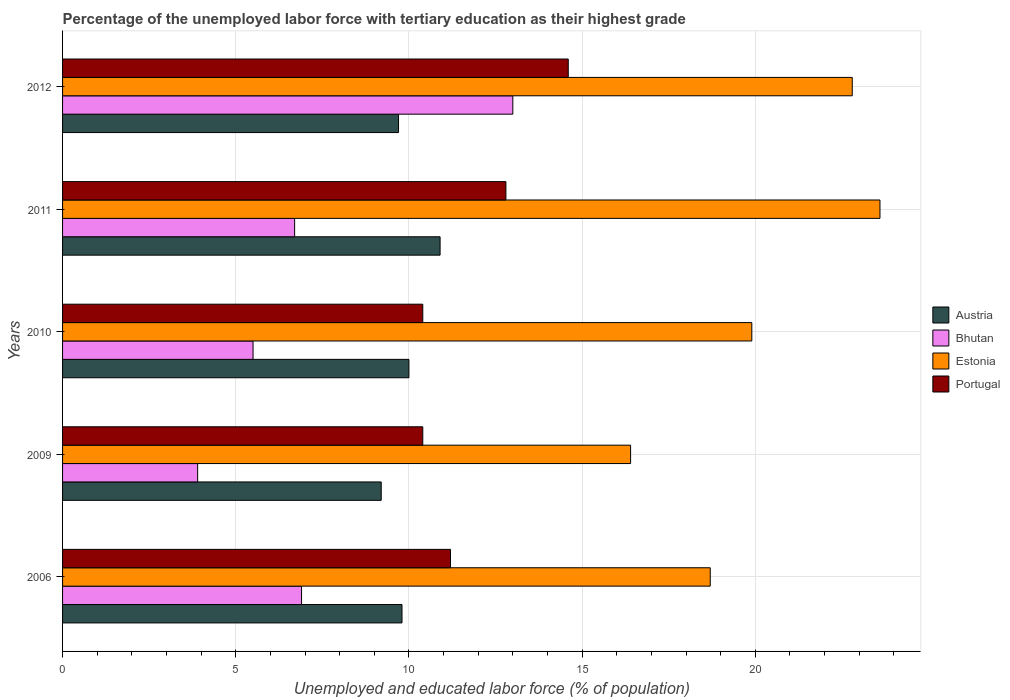Are the number of bars per tick equal to the number of legend labels?
Provide a succinct answer. Yes. Are the number of bars on each tick of the Y-axis equal?
Provide a succinct answer. Yes. What is the label of the 5th group of bars from the top?
Provide a short and direct response. 2006. In how many cases, is the number of bars for a given year not equal to the number of legend labels?
Keep it short and to the point. 0. What is the percentage of the unemployed labor force with tertiary education in Estonia in 2006?
Provide a short and direct response. 18.7. Across all years, what is the maximum percentage of the unemployed labor force with tertiary education in Estonia?
Your answer should be compact. 23.6. Across all years, what is the minimum percentage of the unemployed labor force with tertiary education in Estonia?
Ensure brevity in your answer.  16.4. In which year was the percentage of the unemployed labor force with tertiary education in Portugal maximum?
Make the answer very short. 2012. What is the total percentage of the unemployed labor force with tertiary education in Portugal in the graph?
Give a very brief answer. 59.4. What is the difference between the percentage of the unemployed labor force with tertiary education in Estonia in 2010 and that in 2012?
Make the answer very short. -2.9. What is the difference between the percentage of the unemployed labor force with tertiary education in Bhutan in 2006 and the percentage of the unemployed labor force with tertiary education in Portugal in 2012?
Offer a very short reply. -7.7. What is the average percentage of the unemployed labor force with tertiary education in Bhutan per year?
Provide a short and direct response. 7.2. In the year 2006, what is the difference between the percentage of the unemployed labor force with tertiary education in Estonia and percentage of the unemployed labor force with tertiary education in Portugal?
Keep it short and to the point. 7.5. In how many years, is the percentage of the unemployed labor force with tertiary education in Estonia greater than 19 %?
Provide a succinct answer. 3. What is the ratio of the percentage of the unemployed labor force with tertiary education in Portugal in 2006 to that in 2012?
Your answer should be compact. 0.77. Is the difference between the percentage of the unemployed labor force with tertiary education in Estonia in 2009 and 2012 greater than the difference between the percentage of the unemployed labor force with tertiary education in Portugal in 2009 and 2012?
Offer a terse response. No. What is the difference between the highest and the second highest percentage of the unemployed labor force with tertiary education in Bhutan?
Keep it short and to the point. 6.1. What is the difference between the highest and the lowest percentage of the unemployed labor force with tertiary education in Austria?
Ensure brevity in your answer.  1.7. In how many years, is the percentage of the unemployed labor force with tertiary education in Estonia greater than the average percentage of the unemployed labor force with tertiary education in Estonia taken over all years?
Provide a succinct answer. 2. What does the 4th bar from the top in 2010 represents?
Offer a terse response. Austria. What does the 2nd bar from the bottom in 2012 represents?
Offer a terse response. Bhutan. Is it the case that in every year, the sum of the percentage of the unemployed labor force with tertiary education in Estonia and percentage of the unemployed labor force with tertiary education in Portugal is greater than the percentage of the unemployed labor force with tertiary education in Austria?
Your answer should be very brief. Yes. Are all the bars in the graph horizontal?
Give a very brief answer. Yes. What is the difference between two consecutive major ticks on the X-axis?
Ensure brevity in your answer.  5. Are the values on the major ticks of X-axis written in scientific E-notation?
Provide a succinct answer. No. Does the graph contain any zero values?
Provide a succinct answer. No. What is the title of the graph?
Make the answer very short. Percentage of the unemployed labor force with tertiary education as their highest grade. What is the label or title of the X-axis?
Your answer should be compact. Unemployed and educated labor force (% of population). What is the Unemployed and educated labor force (% of population) in Austria in 2006?
Keep it short and to the point. 9.8. What is the Unemployed and educated labor force (% of population) in Bhutan in 2006?
Make the answer very short. 6.9. What is the Unemployed and educated labor force (% of population) in Estonia in 2006?
Provide a short and direct response. 18.7. What is the Unemployed and educated labor force (% of population) of Portugal in 2006?
Give a very brief answer. 11.2. What is the Unemployed and educated labor force (% of population) in Austria in 2009?
Your answer should be very brief. 9.2. What is the Unemployed and educated labor force (% of population) in Bhutan in 2009?
Keep it short and to the point. 3.9. What is the Unemployed and educated labor force (% of population) of Estonia in 2009?
Provide a short and direct response. 16.4. What is the Unemployed and educated labor force (% of population) in Portugal in 2009?
Make the answer very short. 10.4. What is the Unemployed and educated labor force (% of population) in Estonia in 2010?
Your answer should be compact. 19.9. What is the Unemployed and educated labor force (% of population) in Portugal in 2010?
Give a very brief answer. 10.4. What is the Unemployed and educated labor force (% of population) in Austria in 2011?
Ensure brevity in your answer.  10.9. What is the Unemployed and educated labor force (% of population) of Bhutan in 2011?
Ensure brevity in your answer.  6.7. What is the Unemployed and educated labor force (% of population) in Estonia in 2011?
Your answer should be very brief. 23.6. What is the Unemployed and educated labor force (% of population) of Portugal in 2011?
Your answer should be very brief. 12.8. What is the Unemployed and educated labor force (% of population) of Austria in 2012?
Make the answer very short. 9.7. What is the Unemployed and educated labor force (% of population) of Bhutan in 2012?
Your response must be concise. 13. What is the Unemployed and educated labor force (% of population) in Estonia in 2012?
Your response must be concise. 22.8. What is the Unemployed and educated labor force (% of population) in Portugal in 2012?
Offer a terse response. 14.6. Across all years, what is the maximum Unemployed and educated labor force (% of population) in Austria?
Your answer should be very brief. 10.9. Across all years, what is the maximum Unemployed and educated labor force (% of population) of Estonia?
Keep it short and to the point. 23.6. Across all years, what is the maximum Unemployed and educated labor force (% of population) in Portugal?
Your response must be concise. 14.6. Across all years, what is the minimum Unemployed and educated labor force (% of population) of Austria?
Your answer should be compact. 9.2. Across all years, what is the minimum Unemployed and educated labor force (% of population) in Bhutan?
Make the answer very short. 3.9. Across all years, what is the minimum Unemployed and educated labor force (% of population) in Estonia?
Provide a succinct answer. 16.4. Across all years, what is the minimum Unemployed and educated labor force (% of population) in Portugal?
Your answer should be very brief. 10.4. What is the total Unemployed and educated labor force (% of population) in Austria in the graph?
Your response must be concise. 49.6. What is the total Unemployed and educated labor force (% of population) of Bhutan in the graph?
Provide a short and direct response. 36. What is the total Unemployed and educated labor force (% of population) in Estonia in the graph?
Your answer should be compact. 101.4. What is the total Unemployed and educated labor force (% of population) of Portugal in the graph?
Keep it short and to the point. 59.4. What is the difference between the Unemployed and educated labor force (% of population) of Bhutan in 2006 and that in 2009?
Give a very brief answer. 3. What is the difference between the Unemployed and educated labor force (% of population) of Estonia in 2006 and that in 2009?
Make the answer very short. 2.3. What is the difference between the Unemployed and educated labor force (% of population) of Portugal in 2006 and that in 2009?
Provide a short and direct response. 0.8. What is the difference between the Unemployed and educated labor force (% of population) in Estonia in 2006 and that in 2010?
Your answer should be compact. -1.2. What is the difference between the Unemployed and educated labor force (% of population) of Portugal in 2006 and that in 2010?
Ensure brevity in your answer.  0.8. What is the difference between the Unemployed and educated labor force (% of population) of Austria in 2006 and that in 2011?
Keep it short and to the point. -1.1. What is the difference between the Unemployed and educated labor force (% of population) in Portugal in 2006 and that in 2012?
Keep it short and to the point. -3.4. What is the difference between the Unemployed and educated labor force (% of population) of Bhutan in 2009 and that in 2010?
Offer a terse response. -1.6. What is the difference between the Unemployed and educated labor force (% of population) in Estonia in 2009 and that in 2010?
Make the answer very short. -3.5. What is the difference between the Unemployed and educated labor force (% of population) in Estonia in 2009 and that in 2011?
Keep it short and to the point. -7.2. What is the difference between the Unemployed and educated labor force (% of population) of Portugal in 2009 and that in 2011?
Give a very brief answer. -2.4. What is the difference between the Unemployed and educated labor force (% of population) in Bhutan in 2009 and that in 2012?
Your answer should be compact. -9.1. What is the difference between the Unemployed and educated labor force (% of population) of Portugal in 2009 and that in 2012?
Keep it short and to the point. -4.2. What is the difference between the Unemployed and educated labor force (% of population) of Bhutan in 2010 and that in 2012?
Offer a terse response. -7.5. What is the difference between the Unemployed and educated labor force (% of population) in Estonia in 2010 and that in 2012?
Your answer should be compact. -2.9. What is the difference between the Unemployed and educated labor force (% of population) of Bhutan in 2011 and that in 2012?
Your answer should be very brief. -6.3. What is the difference between the Unemployed and educated labor force (% of population) in Portugal in 2011 and that in 2012?
Ensure brevity in your answer.  -1.8. What is the difference between the Unemployed and educated labor force (% of population) in Austria in 2006 and the Unemployed and educated labor force (% of population) in Portugal in 2009?
Provide a succinct answer. -0.6. What is the difference between the Unemployed and educated labor force (% of population) of Bhutan in 2006 and the Unemployed and educated labor force (% of population) of Estonia in 2009?
Your response must be concise. -9.5. What is the difference between the Unemployed and educated labor force (% of population) in Estonia in 2006 and the Unemployed and educated labor force (% of population) in Portugal in 2009?
Make the answer very short. 8.3. What is the difference between the Unemployed and educated labor force (% of population) in Austria in 2006 and the Unemployed and educated labor force (% of population) in Estonia in 2010?
Your answer should be very brief. -10.1. What is the difference between the Unemployed and educated labor force (% of population) of Bhutan in 2006 and the Unemployed and educated labor force (% of population) of Estonia in 2010?
Offer a terse response. -13. What is the difference between the Unemployed and educated labor force (% of population) in Austria in 2006 and the Unemployed and educated labor force (% of population) in Bhutan in 2011?
Make the answer very short. 3.1. What is the difference between the Unemployed and educated labor force (% of population) in Austria in 2006 and the Unemployed and educated labor force (% of population) in Estonia in 2011?
Give a very brief answer. -13.8. What is the difference between the Unemployed and educated labor force (% of population) in Bhutan in 2006 and the Unemployed and educated labor force (% of population) in Estonia in 2011?
Provide a short and direct response. -16.7. What is the difference between the Unemployed and educated labor force (% of population) of Bhutan in 2006 and the Unemployed and educated labor force (% of population) of Portugal in 2011?
Give a very brief answer. -5.9. What is the difference between the Unemployed and educated labor force (% of population) of Estonia in 2006 and the Unemployed and educated labor force (% of population) of Portugal in 2011?
Keep it short and to the point. 5.9. What is the difference between the Unemployed and educated labor force (% of population) of Austria in 2006 and the Unemployed and educated labor force (% of population) of Estonia in 2012?
Your answer should be compact. -13. What is the difference between the Unemployed and educated labor force (% of population) of Bhutan in 2006 and the Unemployed and educated labor force (% of population) of Estonia in 2012?
Provide a short and direct response. -15.9. What is the difference between the Unemployed and educated labor force (% of population) of Bhutan in 2006 and the Unemployed and educated labor force (% of population) of Portugal in 2012?
Ensure brevity in your answer.  -7.7. What is the difference between the Unemployed and educated labor force (% of population) in Estonia in 2006 and the Unemployed and educated labor force (% of population) in Portugal in 2012?
Your answer should be very brief. 4.1. What is the difference between the Unemployed and educated labor force (% of population) in Bhutan in 2009 and the Unemployed and educated labor force (% of population) in Portugal in 2010?
Provide a succinct answer. -6.5. What is the difference between the Unemployed and educated labor force (% of population) in Austria in 2009 and the Unemployed and educated labor force (% of population) in Estonia in 2011?
Provide a short and direct response. -14.4. What is the difference between the Unemployed and educated labor force (% of population) in Bhutan in 2009 and the Unemployed and educated labor force (% of population) in Estonia in 2011?
Offer a very short reply. -19.7. What is the difference between the Unemployed and educated labor force (% of population) in Bhutan in 2009 and the Unemployed and educated labor force (% of population) in Portugal in 2011?
Offer a terse response. -8.9. What is the difference between the Unemployed and educated labor force (% of population) of Estonia in 2009 and the Unemployed and educated labor force (% of population) of Portugal in 2011?
Offer a terse response. 3.6. What is the difference between the Unemployed and educated labor force (% of population) in Austria in 2009 and the Unemployed and educated labor force (% of population) in Bhutan in 2012?
Provide a short and direct response. -3.8. What is the difference between the Unemployed and educated labor force (% of population) of Austria in 2009 and the Unemployed and educated labor force (% of population) of Estonia in 2012?
Offer a very short reply. -13.6. What is the difference between the Unemployed and educated labor force (% of population) of Austria in 2009 and the Unemployed and educated labor force (% of population) of Portugal in 2012?
Give a very brief answer. -5.4. What is the difference between the Unemployed and educated labor force (% of population) of Bhutan in 2009 and the Unemployed and educated labor force (% of population) of Estonia in 2012?
Your answer should be very brief. -18.9. What is the difference between the Unemployed and educated labor force (% of population) of Austria in 2010 and the Unemployed and educated labor force (% of population) of Bhutan in 2011?
Ensure brevity in your answer.  3.3. What is the difference between the Unemployed and educated labor force (% of population) of Austria in 2010 and the Unemployed and educated labor force (% of population) of Estonia in 2011?
Your answer should be very brief. -13.6. What is the difference between the Unemployed and educated labor force (% of population) in Austria in 2010 and the Unemployed and educated labor force (% of population) in Portugal in 2011?
Provide a succinct answer. -2.8. What is the difference between the Unemployed and educated labor force (% of population) in Bhutan in 2010 and the Unemployed and educated labor force (% of population) in Estonia in 2011?
Your answer should be very brief. -18.1. What is the difference between the Unemployed and educated labor force (% of population) of Estonia in 2010 and the Unemployed and educated labor force (% of population) of Portugal in 2011?
Provide a short and direct response. 7.1. What is the difference between the Unemployed and educated labor force (% of population) in Austria in 2010 and the Unemployed and educated labor force (% of population) in Estonia in 2012?
Provide a short and direct response. -12.8. What is the difference between the Unemployed and educated labor force (% of population) in Austria in 2010 and the Unemployed and educated labor force (% of population) in Portugal in 2012?
Make the answer very short. -4.6. What is the difference between the Unemployed and educated labor force (% of population) in Bhutan in 2010 and the Unemployed and educated labor force (% of population) in Estonia in 2012?
Offer a terse response. -17.3. What is the difference between the Unemployed and educated labor force (% of population) of Austria in 2011 and the Unemployed and educated labor force (% of population) of Estonia in 2012?
Your answer should be very brief. -11.9. What is the difference between the Unemployed and educated labor force (% of population) of Austria in 2011 and the Unemployed and educated labor force (% of population) of Portugal in 2012?
Make the answer very short. -3.7. What is the difference between the Unemployed and educated labor force (% of population) in Bhutan in 2011 and the Unemployed and educated labor force (% of population) in Estonia in 2012?
Provide a succinct answer. -16.1. What is the difference between the Unemployed and educated labor force (% of population) in Bhutan in 2011 and the Unemployed and educated labor force (% of population) in Portugal in 2012?
Provide a short and direct response. -7.9. What is the average Unemployed and educated labor force (% of population) of Austria per year?
Ensure brevity in your answer.  9.92. What is the average Unemployed and educated labor force (% of population) of Bhutan per year?
Give a very brief answer. 7.2. What is the average Unemployed and educated labor force (% of population) of Estonia per year?
Ensure brevity in your answer.  20.28. What is the average Unemployed and educated labor force (% of population) in Portugal per year?
Your response must be concise. 11.88. In the year 2006, what is the difference between the Unemployed and educated labor force (% of population) in Bhutan and Unemployed and educated labor force (% of population) in Portugal?
Your answer should be very brief. -4.3. In the year 2009, what is the difference between the Unemployed and educated labor force (% of population) in Austria and Unemployed and educated labor force (% of population) in Bhutan?
Keep it short and to the point. 5.3. In the year 2009, what is the difference between the Unemployed and educated labor force (% of population) of Austria and Unemployed and educated labor force (% of population) of Estonia?
Offer a terse response. -7.2. In the year 2009, what is the difference between the Unemployed and educated labor force (% of population) in Estonia and Unemployed and educated labor force (% of population) in Portugal?
Offer a very short reply. 6. In the year 2010, what is the difference between the Unemployed and educated labor force (% of population) in Austria and Unemployed and educated labor force (% of population) in Estonia?
Provide a succinct answer. -9.9. In the year 2010, what is the difference between the Unemployed and educated labor force (% of population) in Austria and Unemployed and educated labor force (% of population) in Portugal?
Provide a short and direct response. -0.4. In the year 2010, what is the difference between the Unemployed and educated labor force (% of population) in Bhutan and Unemployed and educated labor force (% of population) in Estonia?
Ensure brevity in your answer.  -14.4. In the year 2011, what is the difference between the Unemployed and educated labor force (% of population) in Bhutan and Unemployed and educated labor force (% of population) in Estonia?
Your response must be concise. -16.9. In the year 2011, what is the difference between the Unemployed and educated labor force (% of population) of Estonia and Unemployed and educated labor force (% of population) of Portugal?
Give a very brief answer. 10.8. In the year 2012, what is the difference between the Unemployed and educated labor force (% of population) of Bhutan and Unemployed and educated labor force (% of population) of Estonia?
Offer a terse response. -9.8. In the year 2012, what is the difference between the Unemployed and educated labor force (% of population) in Bhutan and Unemployed and educated labor force (% of population) in Portugal?
Provide a short and direct response. -1.6. In the year 2012, what is the difference between the Unemployed and educated labor force (% of population) of Estonia and Unemployed and educated labor force (% of population) of Portugal?
Keep it short and to the point. 8.2. What is the ratio of the Unemployed and educated labor force (% of population) in Austria in 2006 to that in 2009?
Your answer should be compact. 1.07. What is the ratio of the Unemployed and educated labor force (% of population) in Bhutan in 2006 to that in 2009?
Offer a terse response. 1.77. What is the ratio of the Unemployed and educated labor force (% of population) in Estonia in 2006 to that in 2009?
Ensure brevity in your answer.  1.14. What is the ratio of the Unemployed and educated labor force (% of population) of Austria in 2006 to that in 2010?
Provide a short and direct response. 0.98. What is the ratio of the Unemployed and educated labor force (% of population) of Bhutan in 2006 to that in 2010?
Keep it short and to the point. 1.25. What is the ratio of the Unemployed and educated labor force (% of population) in Estonia in 2006 to that in 2010?
Your response must be concise. 0.94. What is the ratio of the Unemployed and educated labor force (% of population) in Austria in 2006 to that in 2011?
Keep it short and to the point. 0.9. What is the ratio of the Unemployed and educated labor force (% of population) in Bhutan in 2006 to that in 2011?
Keep it short and to the point. 1.03. What is the ratio of the Unemployed and educated labor force (% of population) of Estonia in 2006 to that in 2011?
Give a very brief answer. 0.79. What is the ratio of the Unemployed and educated labor force (% of population) in Austria in 2006 to that in 2012?
Keep it short and to the point. 1.01. What is the ratio of the Unemployed and educated labor force (% of population) of Bhutan in 2006 to that in 2012?
Offer a very short reply. 0.53. What is the ratio of the Unemployed and educated labor force (% of population) in Estonia in 2006 to that in 2012?
Provide a short and direct response. 0.82. What is the ratio of the Unemployed and educated labor force (% of population) in Portugal in 2006 to that in 2012?
Your answer should be compact. 0.77. What is the ratio of the Unemployed and educated labor force (% of population) of Austria in 2009 to that in 2010?
Your answer should be compact. 0.92. What is the ratio of the Unemployed and educated labor force (% of population) in Bhutan in 2009 to that in 2010?
Make the answer very short. 0.71. What is the ratio of the Unemployed and educated labor force (% of population) in Estonia in 2009 to that in 2010?
Offer a terse response. 0.82. What is the ratio of the Unemployed and educated labor force (% of population) in Portugal in 2009 to that in 2010?
Provide a short and direct response. 1. What is the ratio of the Unemployed and educated labor force (% of population) in Austria in 2009 to that in 2011?
Offer a terse response. 0.84. What is the ratio of the Unemployed and educated labor force (% of population) of Bhutan in 2009 to that in 2011?
Your response must be concise. 0.58. What is the ratio of the Unemployed and educated labor force (% of population) in Estonia in 2009 to that in 2011?
Your answer should be very brief. 0.69. What is the ratio of the Unemployed and educated labor force (% of population) of Portugal in 2009 to that in 2011?
Provide a succinct answer. 0.81. What is the ratio of the Unemployed and educated labor force (% of population) of Austria in 2009 to that in 2012?
Give a very brief answer. 0.95. What is the ratio of the Unemployed and educated labor force (% of population) in Bhutan in 2009 to that in 2012?
Provide a short and direct response. 0.3. What is the ratio of the Unemployed and educated labor force (% of population) in Estonia in 2009 to that in 2012?
Your response must be concise. 0.72. What is the ratio of the Unemployed and educated labor force (% of population) in Portugal in 2009 to that in 2012?
Ensure brevity in your answer.  0.71. What is the ratio of the Unemployed and educated labor force (% of population) of Austria in 2010 to that in 2011?
Provide a short and direct response. 0.92. What is the ratio of the Unemployed and educated labor force (% of population) of Bhutan in 2010 to that in 2011?
Offer a very short reply. 0.82. What is the ratio of the Unemployed and educated labor force (% of population) of Estonia in 2010 to that in 2011?
Offer a very short reply. 0.84. What is the ratio of the Unemployed and educated labor force (% of population) of Portugal in 2010 to that in 2011?
Provide a short and direct response. 0.81. What is the ratio of the Unemployed and educated labor force (% of population) of Austria in 2010 to that in 2012?
Your answer should be compact. 1.03. What is the ratio of the Unemployed and educated labor force (% of population) in Bhutan in 2010 to that in 2012?
Offer a very short reply. 0.42. What is the ratio of the Unemployed and educated labor force (% of population) in Estonia in 2010 to that in 2012?
Offer a terse response. 0.87. What is the ratio of the Unemployed and educated labor force (% of population) in Portugal in 2010 to that in 2012?
Give a very brief answer. 0.71. What is the ratio of the Unemployed and educated labor force (% of population) of Austria in 2011 to that in 2012?
Provide a short and direct response. 1.12. What is the ratio of the Unemployed and educated labor force (% of population) in Bhutan in 2011 to that in 2012?
Your answer should be very brief. 0.52. What is the ratio of the Unemployed and educated labor force (% of population) in Estonia in 2011 to that in 2012?
Your answer should be compact. 1.04. What is the ratio of the Unemployed and educated labor force (% of population) of Portugal in 2011 to that in 2012?
Give a very brief answer. 0.88. What is the difference between the highest and the second highest Unemployed and educated labor force (% of population) of Bhutan?
Make the answer very short. 6.1. What is the difference between the highest and the second highest Unemployed and educated labor force (% of population) in Portugal?
Your answer should be very brief. 1.8. What is the difference between the highest and the lowest Unemployed and educated labor force (% of population) of Austria?
Make the answer very short. 1.7. What is the difference between the highest and the lowest Unemployed and educated labor force (% of population) in Bhutan?
Offer a terse response. 9.1. What is the difference between the highest and the lowest Unemployed and educated labor force (% of population) of Portugal?
Your response must be concise. 4.2. 